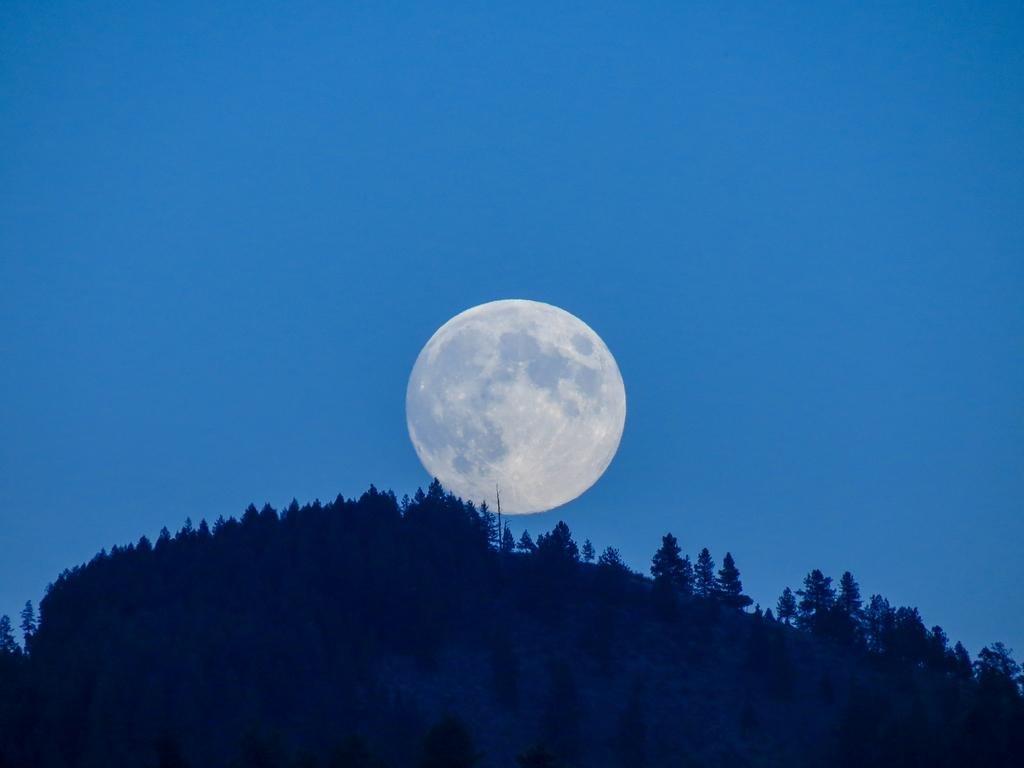What type of vegetation is at the bottom of the image? There are trees at the bottom of the image. What celestial object is in the middle of the image? The moon is in the middle of the image. What part of the natural environment is visible in the background of the image? The sky is visible in the background of the image. What advice does the mom give to the father in the image? There is no mom or father present in the image, as it features trees and the moon. How does the mist affect the visibility of the trees in the image? There is no mist present in the image; it features clear trees and the moon. 